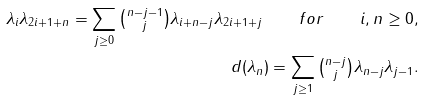<formula> <loc_0><loc_0><loc_500><loc_500>\lambda _ { i } \lambda _ { 2 i + 1 + n } = \sum _ { j \geq 0 } \tbinom { n - j - 1 } { j } \lambda _ { i + n - j } \lambda _ { 2 i + 1 + j } \quad f o r \quad i , n \geq 0 , \\ d ( \lambda _ { n } ) = \sum _ { j \geq 1 } \tbinom { n - j } { j } \lambda _ { n - j } \lambda _ { j - 1 } .</formula> 